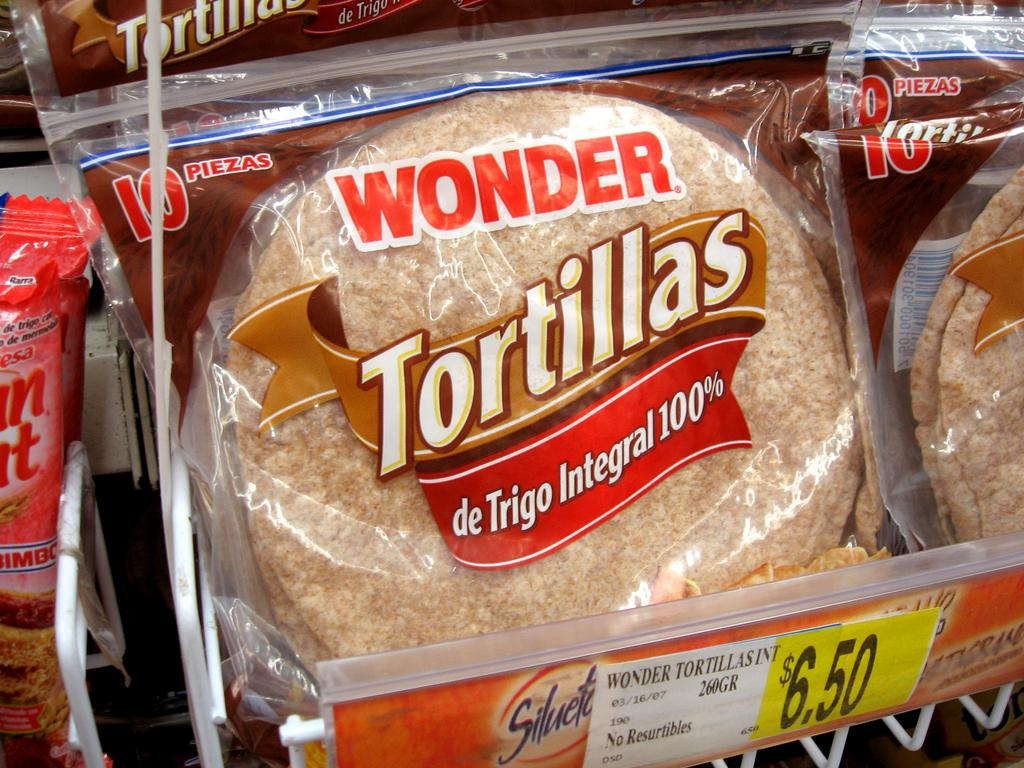What type of food items are visible in the image? There are food items with covers in the image. What can be seen on the covers of the food items? The covers have logos on them. Where are the food items placed in the image? The food items are kept on a shelf. Is there any information about the cost of the food items in the image? Yes, there is a price tag visible in the image. Is there any blood or wound visible on the food items in the image? No, there is no blood or wound visible on the food items in the image. What type of yoke is used to carry the food items in the image? There is no yoke present in the image; the food items are kept on a shelf. 